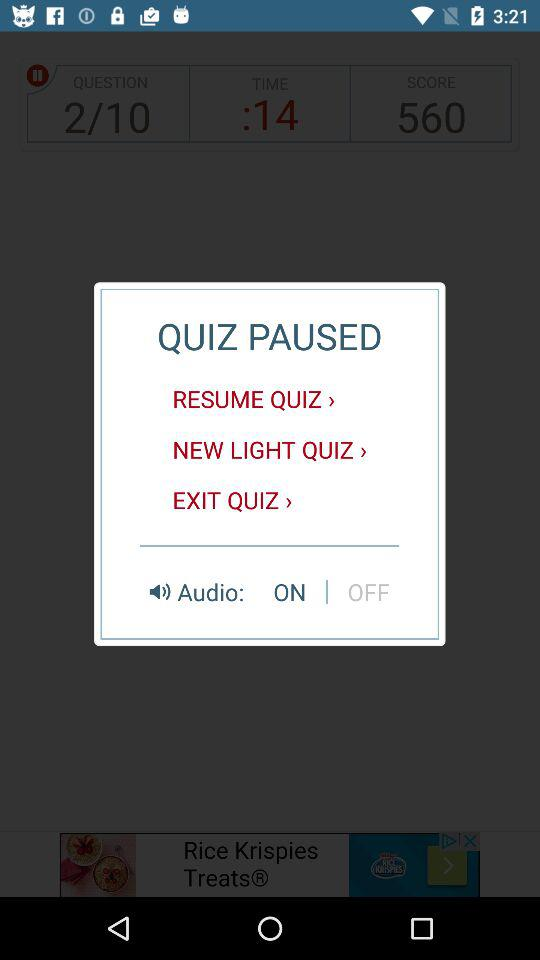What is the status of "Audio"? The status is "on". 